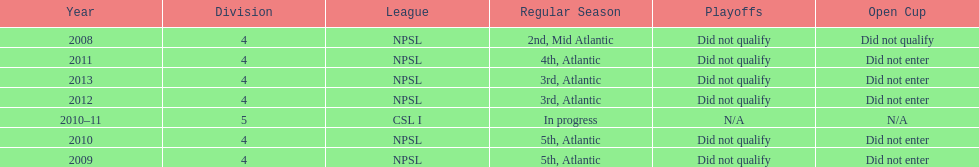What is the lowest place they came in 5th. 